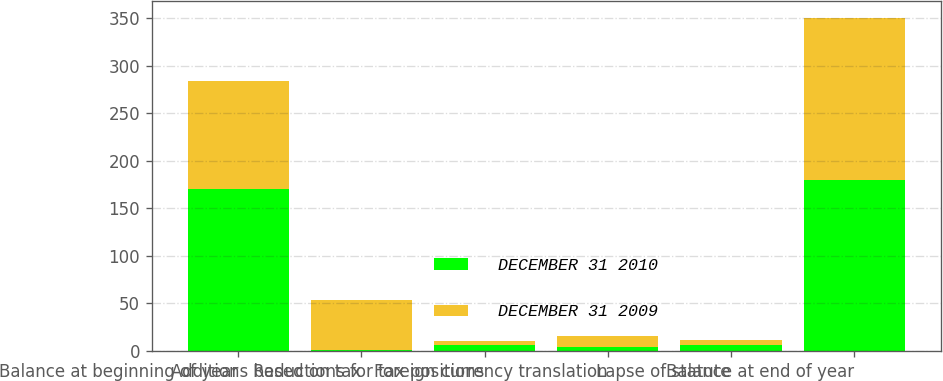<chart> <loc_0><loc_0><loc_500><loc_500><stacked_bar_chart><ecel><fcel>Balance at beginning of year<fcel>Additions based on tax<fcel>Reductions for tax positions<fcel>Foreign currency translation<fcel>Lapse of statute<fcel>Balance at end of year<nl><fcel>DECEMBER 31 2010<fcel>170<fcel>1<fcel>6<fcel>4<fcel>6<fcel>180<nl><fcel>DECEMBER 31 2009<fcel>114<fcel>53<fcel>4<fcel>12<fcel>5<fcel>170<nl></chart> 